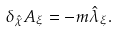Convert formula to latex. <formula><loc_0><loc_0><loc_500><loc_500>\delta _ { \hat { \chi } } A _ { \xi } = - m \hat { \lambda } _ { \xi } .</formula> 